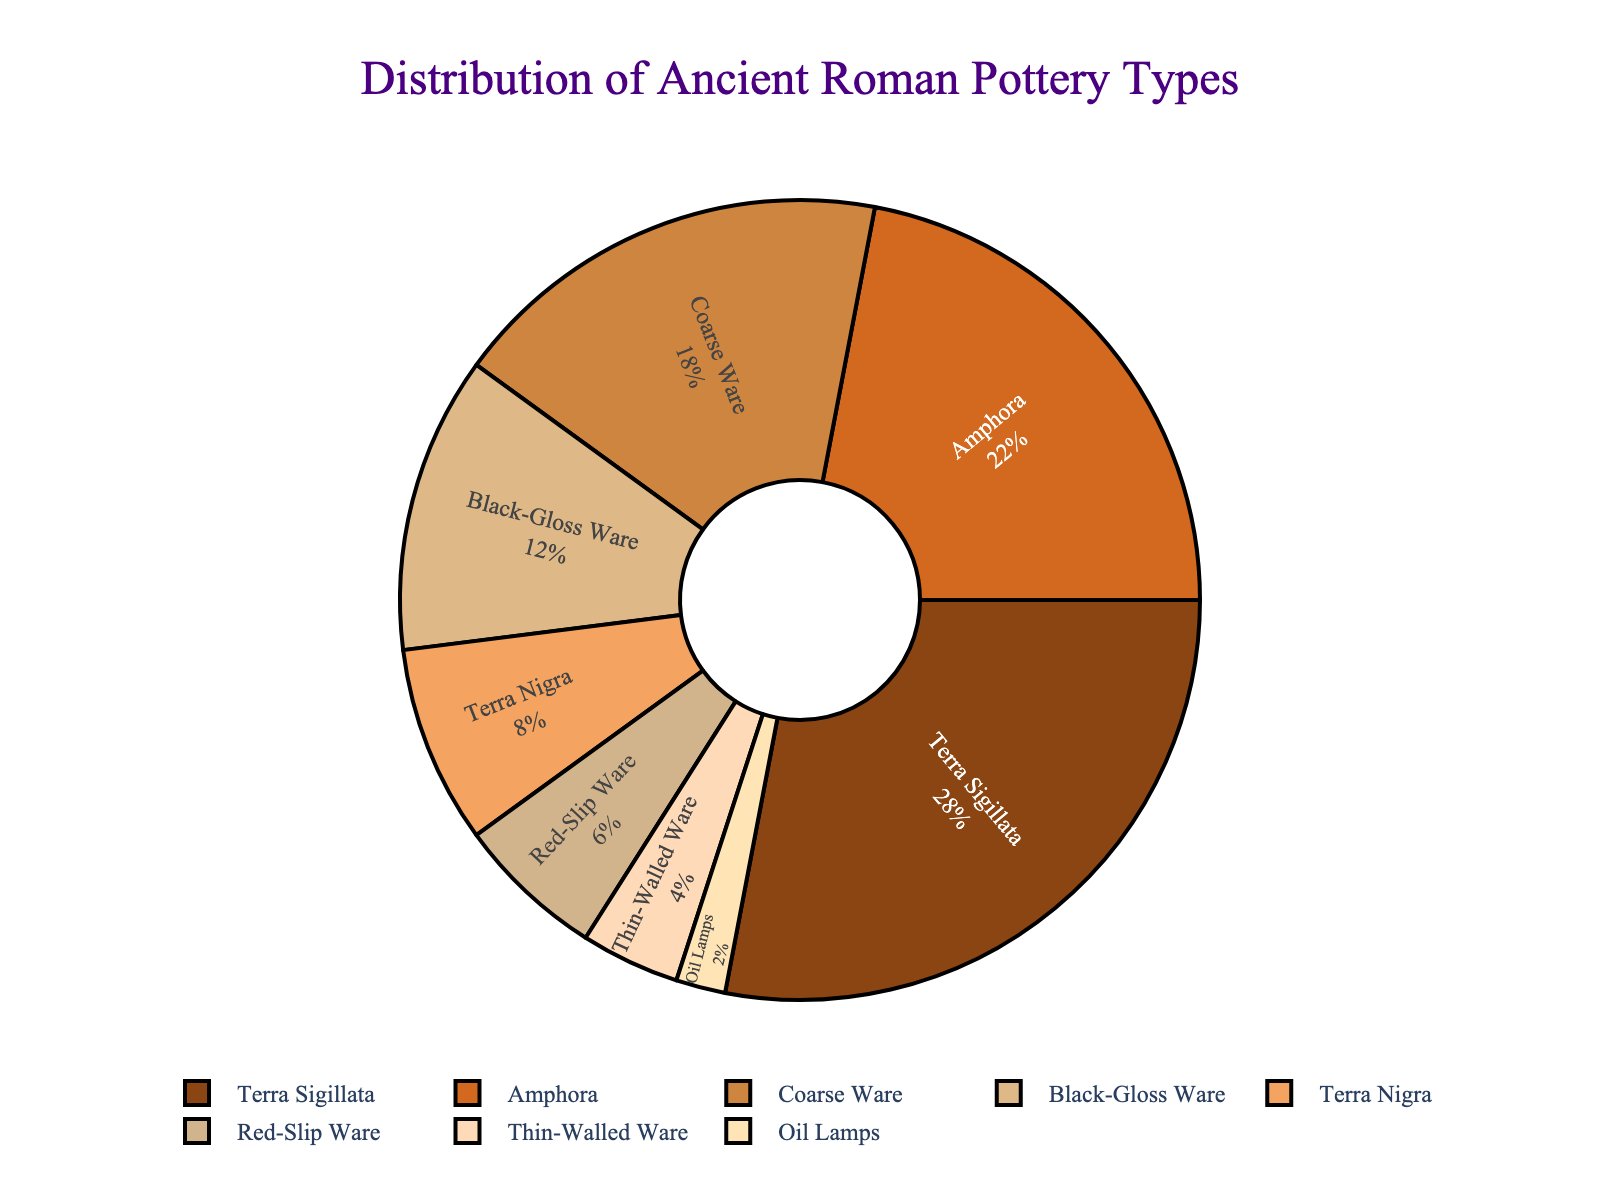what is the most common ancient Roman pottery type found based on the chart? The largest portion of the pie chart represents Terra Sigillata, indicating it is the most common type.
Answer: Terra Sigillata Which two pottery types combined make up 30% of the total distribution? Terra Nigra makes up 8% and Red-Slip Ware makes up 6%. Combined, these total to 14%. Adding Thin-Walled Ware (4%) makes a sum of 18%. Thus, combining Coarse Ware (18%) and Black-Gloss Ware (12%) gives us 18% + 12% = 30%.
Answer: Coarse Ware and Black-Gloss Ware How much larger is the percentage of Terra Sigillata compared to Oil Lamps? Terra Sigillata is 28% and Oil Lamps are 2%. Subtracting the smaller percentage from the larger gives us 28% - 2% = 26%.
Answer: 26% What proportion of the chart is taken up by Amphora and Coarse Ware together? Amphora accounts for 22% and Coarse Ware accounts for 18%. Adding these values gives us 22% + 18% = 40%.
Answer: 40% Which pottery type has the smallest share in the distribution? The smallest portion of the pie chart represents Oil Lamps, indicating it is the least common type found.
Answer: Oil Lamps How does Thin-Walled Ware's percentage compare to Terra Nigra's? Thin-Walled Ware makes up 4% and Terra Nigra makes up 8%. Therefore, Terra Nigra's percentage is double that of Thin-Walled Ware.
Answer: Terra Nigra's percentage is double that of Thin-Walled Ware Which type of pottery holds the middle position in terms of its percentage share? Sorting the types by their percentages, the middle type is Black-Gloss Ware, which makes up 12% of the total.
Answer: Black-Gloss Ware If you combine Terra Nigra, Red-Slip Ware, and Thin-Walled Ware, what percentage of the total distribution do you get? Terra Nigra is 8%, Red-Slip Ware is 6%, and Thin-Walled Ware is 4%. Summing these gives us 8% + 6% + 4% = 18%.
Answer: 18% 